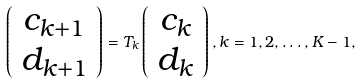Convert formula to latex. <formula><loc_0><loc_0><loc_500><loc_500>\left ( \begin{array} { c } c _ { k + 1 } \\ d _ { k + 1 } \end{array} \right ) = T _ { k } \left ( \begin{array} { c } c _ { k } \\ d _ { k } \end{array} \right ) , k = 1 , 2 , \dots , K - 1 ,</formula> 